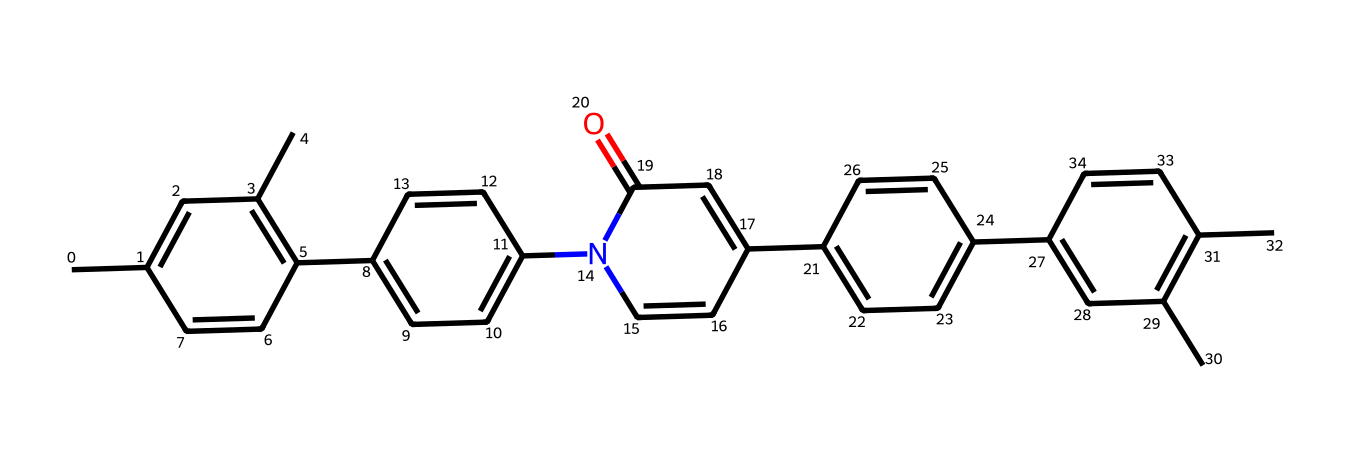What is the total number of carbon atoms in this chemical? To find the total number of carbon atoms, we need to carefully count each carbon (C) in the structural representation of the chemical. Upon deciphering the SMILES, we identify that there are 30 carbon atoms represented in various rings and chains.
Answer: 30 How many nitrogen atoms are present in this chemical? In the provided SMILES structure, we look for the nitrogen (N) symbols. Examining the structure reveals that there is one nitrogen atom present in the entire chemical structure.
Answer: 1 What functional group is located in this chemical compound? By analyzing the structure, we note that the compound contains a carbonyl group (C=O) present in the cyclic part of the chemical. This is indicated by the presence of the carbon atom bonded to the double-bonded oxygen.
Answer: carbonyl Which part of this chemical is responsible for its liquid crystal properties? The arrangement of the double bonds and the presence of the cyclic structures encourage the alignment of molecules necessary for liquid crystal properties. Specifically, the aromatic rings play a crucial role in creating the required anisotropic behavior.
Answer: aromatic rings What type of chemical structure does this compound represent? Assessing the features of the chemical structure, we can identify that this compound is an organic compound with multiple ring systems and functional groups, typical of liquid crystals used in displays. Hence, it can be classified as a liquid crystal.
Answer: liquid crystal How many distinct rings are present in this chemical structure? To determine the number of rings, we inspect the SMILES. The chemical features five distinct aromatic rings (which typically are hexagonal), corresponding to the interconnected structure denoted by the notation in the SMILES.
Answer: 5 What is the significance of the nitrogen atom in this chemical? The nitrogen atom introduces heteroatoms into the structure, which can influence the electronic properties and enhance the alignment in liquid crystal displays. Its position in the cyclic structure also helps stabilize the overall conformation.
Answer: electronic properties 